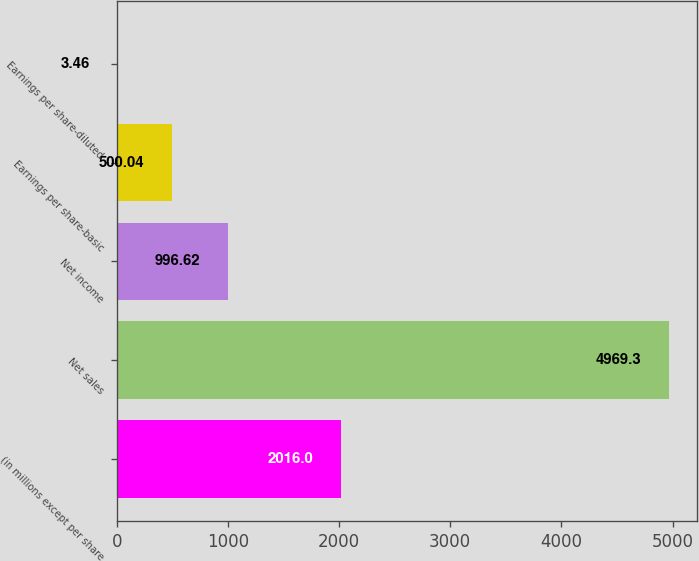Convert chart. <chart><loc_0><loc_0><loc_500><loc_500><bar_chart><fcel>(in millions except per share<fcel>Net sales<fcel>Net income<fcel>Earnings per share-basic<fcel>Earnings per share-diluted<nl><fcel>2016<fcel>4969.3<fcel>996.62<fcel>500.04<fcel>3.46<nl></chart> 